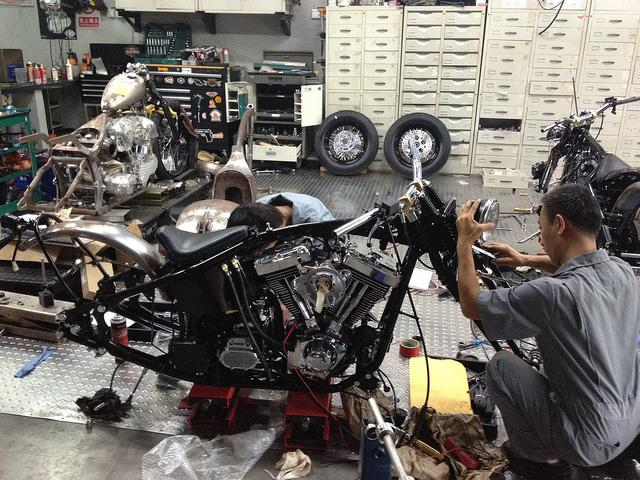What are the cabinets in the background called?

Choices:
A) safety cabinets
B) tool cabinets
C) safes
D) file cabinets safes 